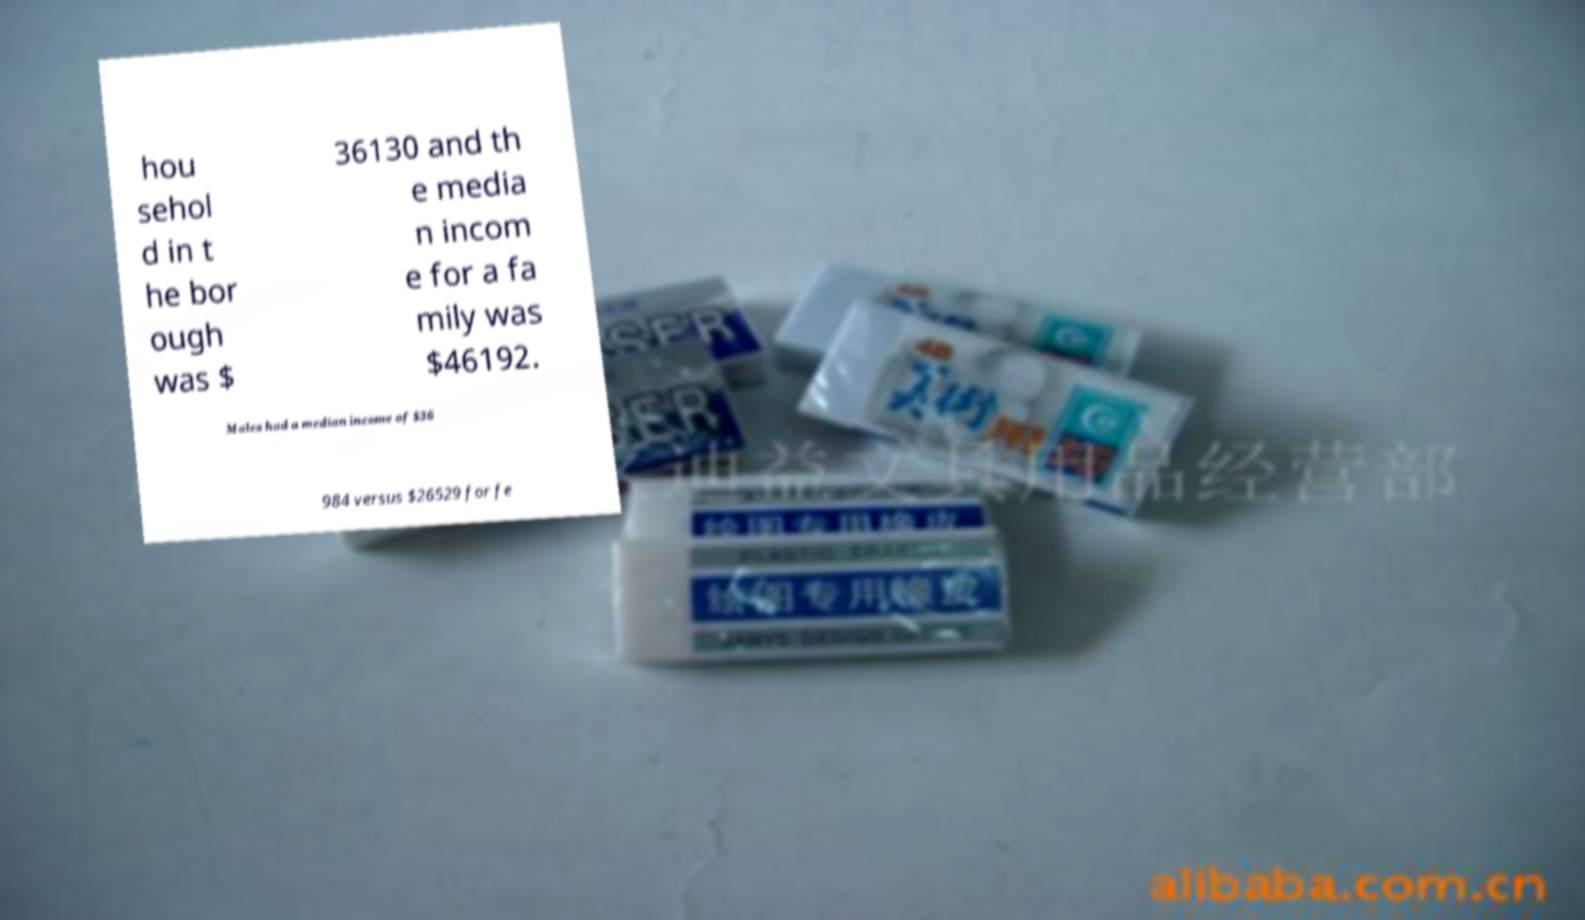Could you assist in decoding the text presented in this image and type it out clearly? hou sehol d in t he bor ough was $ 36130 and th e media n incom e for a fa mily was $46192. Males had a median income of $36 984 versus $26529 for fe 